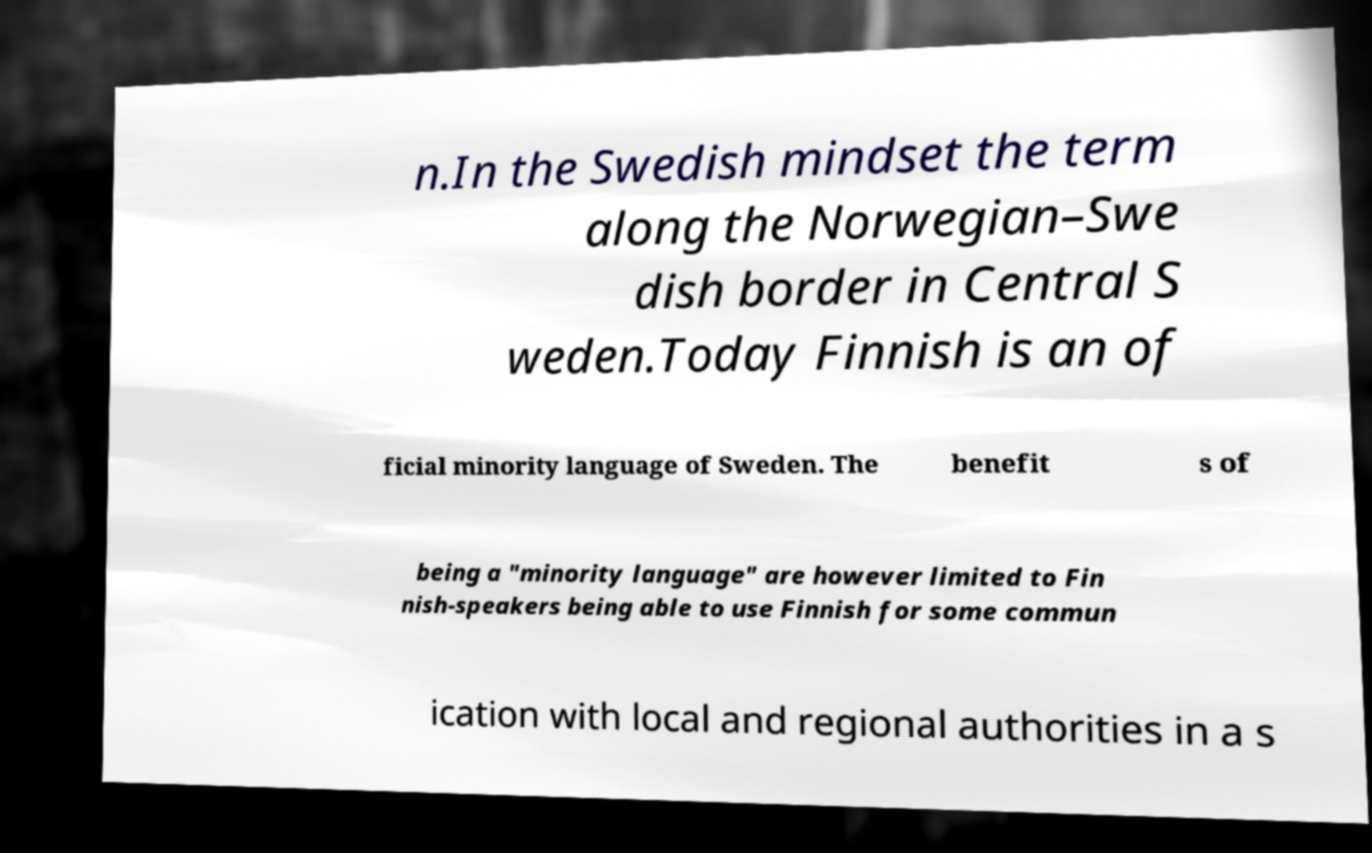Can you accurately transcribe the text from the provided image for me? n.In the Swedish mindset the term along the Norwegian–Swe dish border in Central S weden.Today Finnish is an of ficial minority language of Sweden. The benefit s of being a "minority language" are however limited to Fin nish-speakers being able to use Finnish for some commun ication with local and regional authorities in a s 